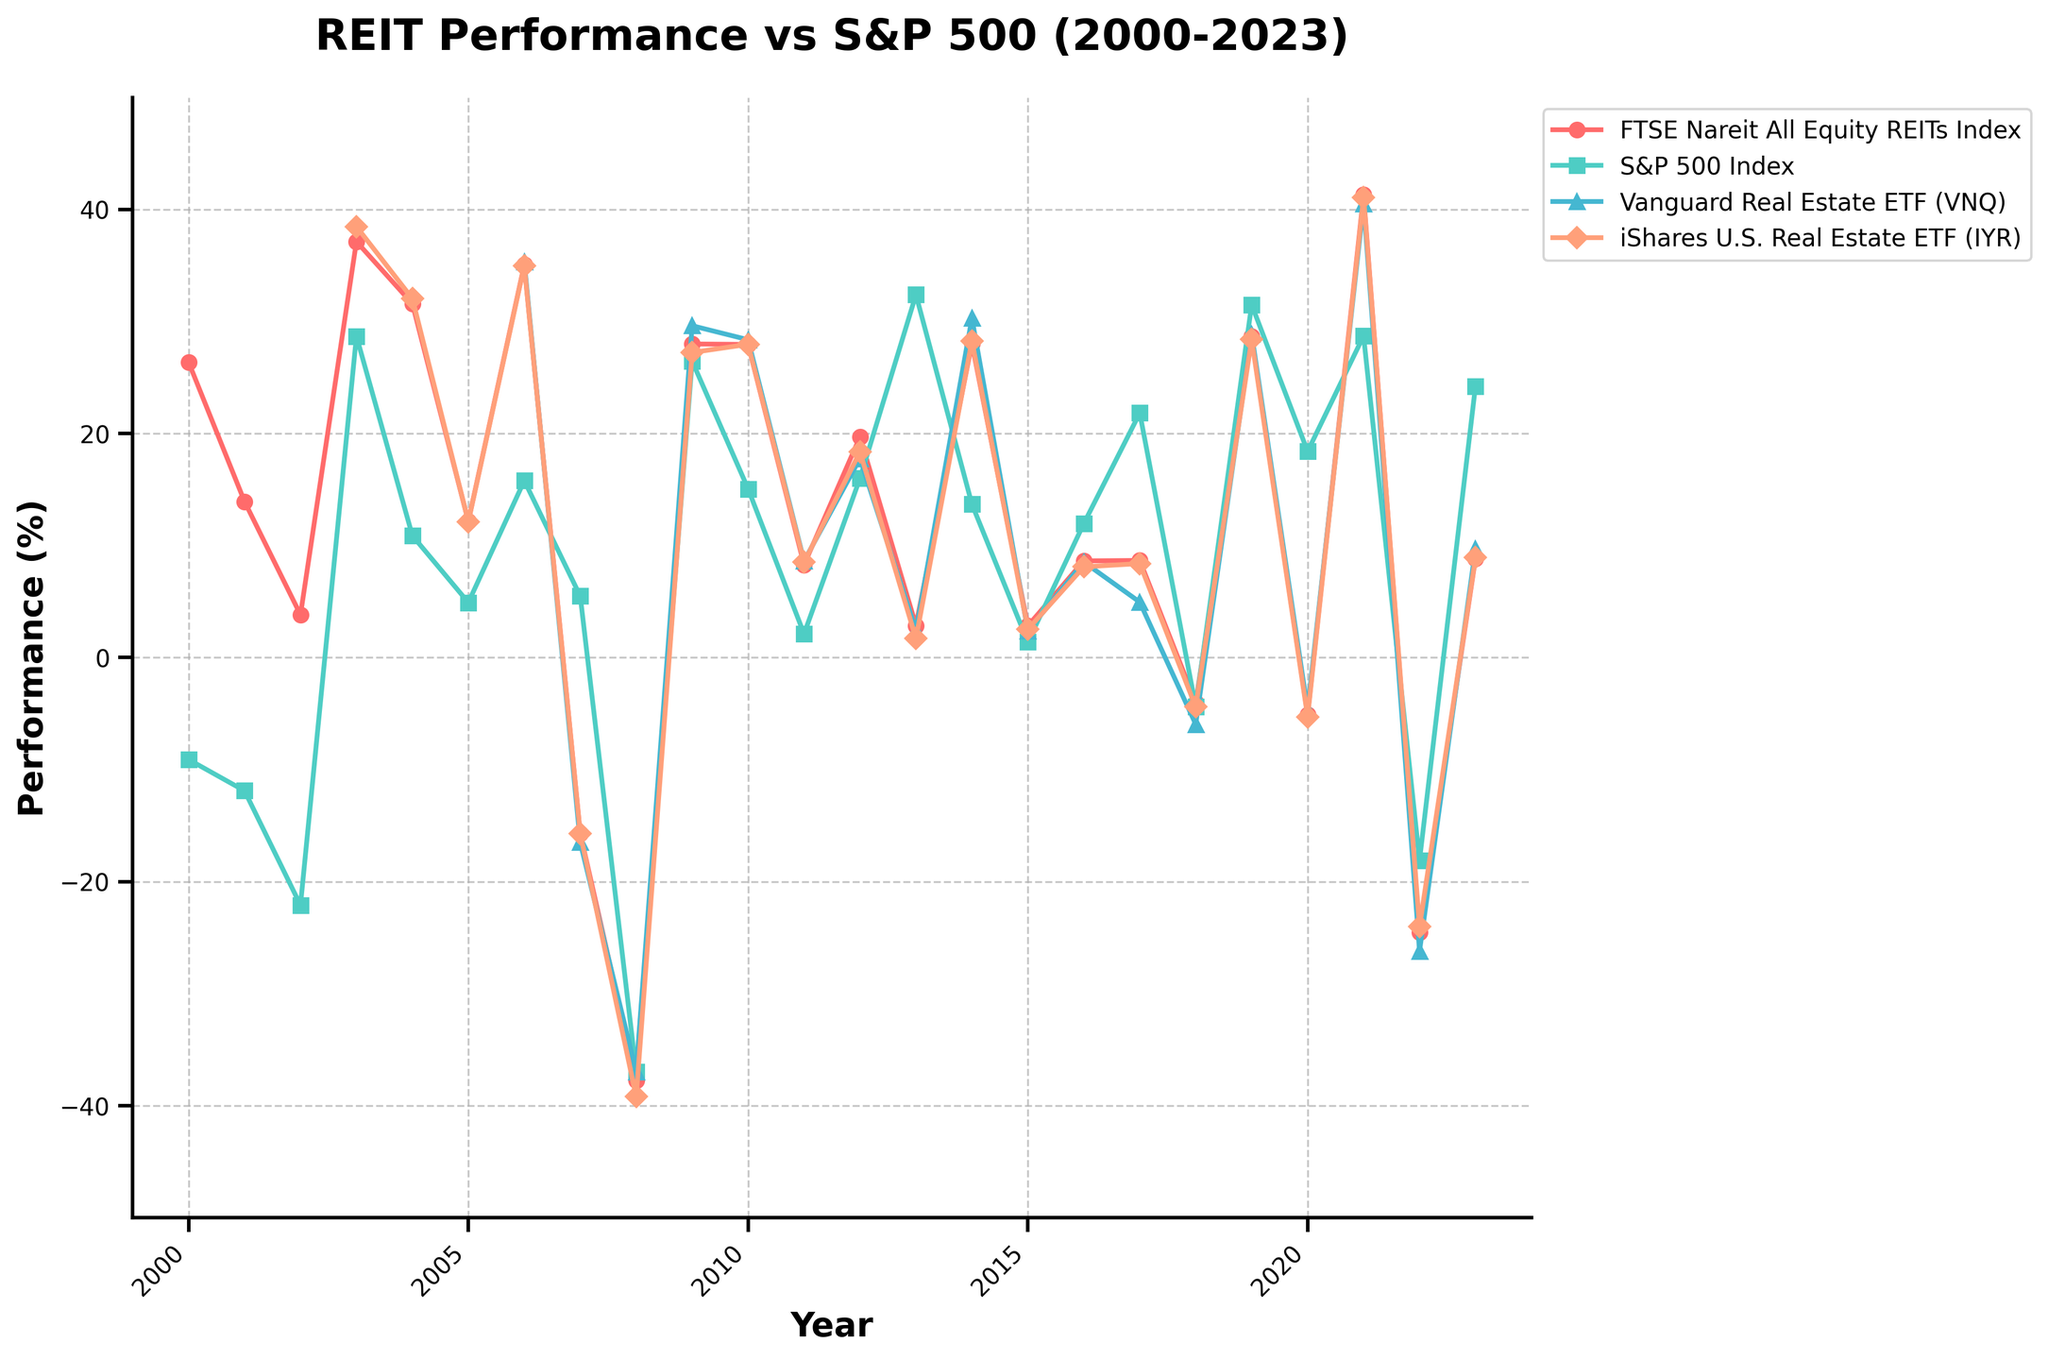Which index had the highest performance in 2021? Look at the lines corresponding to 2021. The FTSE Nareit All Equity REITs Index (red) reached around 41.30%, higher than the S&P 500 Index (green) at 28.71%, Vanguard Real Estate ETF (VNQ) at 40.52%, and iShares U.S. Real Estate ETF (IYR) at 41.08%.
Answer: FTSE Nareit All Equity REITs Index How did the S&P 500 Index perform in 2008 compared to iShares U.S. Real Estate ETF (IYR)? Observe the data points for 2008. The S&P 500 Index (green) is at -37.00%, while iShares U.S. Real Estate ETF (IYR) (orange) is at -39.20%. The S&P 500 Index performed slightly better.
Answer: S&P 500 Index performed better What is the average performance of Vanguard Real Estate ETF (VNQ) in 2016 and 2017? For 2016, VNQ's performance is 8.53%, and for 2017, it's 4.95%. The average is (8.53 + 4.95) / 2.
Answer: 6.74% In which year did FTSE Nareit All Equity REITs Index have its lowest performance, and what was the value? Scan the red line for the minimum point, which happens in 2008 at -37.73%.
Answer: 2008, -37.73% Which investment performed the worst in 2022? Look at the data points for 2022. The Vanguard Real Estate ETF (VNQ) (blue) had the lowest value at -26.21%, followed closely by FTSE Nareit All Equity REITs Index (red) at -24.51% and iShares U.S. Real Estate ETF (IYR) (orange) at -24.00%.
Answer: Vanguard Real Estate ETF (VNQ) During which years did FTSE Nareit All Equity REITs Index outperform the S&P 500 Index? Identify the years when the red line is above the green line. The FTSE Nareit All Equity REITs Index outperformed the S&P 500 Index in multiple years such as 2000, 2001, 2002, 2004, 2006, and more.
Answer: Several years, including 2000, 2001, 2002, 2004, 2006 What is the difference in performance between FTSE Nareit All Equity REITs Index and S&P 500 Index in 2014? In 2014, FTSE Nareit All Equity REITs Index performed at 28.03%, and S&P 500 Index at 13.69%. The difference is 28.03 - 13.69.
Answer: 14.34% 